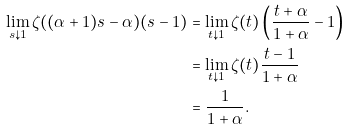<formula> <loc_0><loc_0><loc_500><loc_500>\lim _ { s \downarrow 1 } \zeta ( ( \alpha + 1 ) s - \alpha ) ( s - 1 ) & = \lim _ { t \downarrow 1 } \zeta ( t ) \left ( \frac { t + \alpha } { 1 + \alpha } - 1 \right ) \\ & = \lim _ { t \downarrow 1 } \zeta ( t ) \frac { t - 1 } { 1 + \alpha } \\ & = \frac { 1 } { 1 + \alpha } .</formula> 